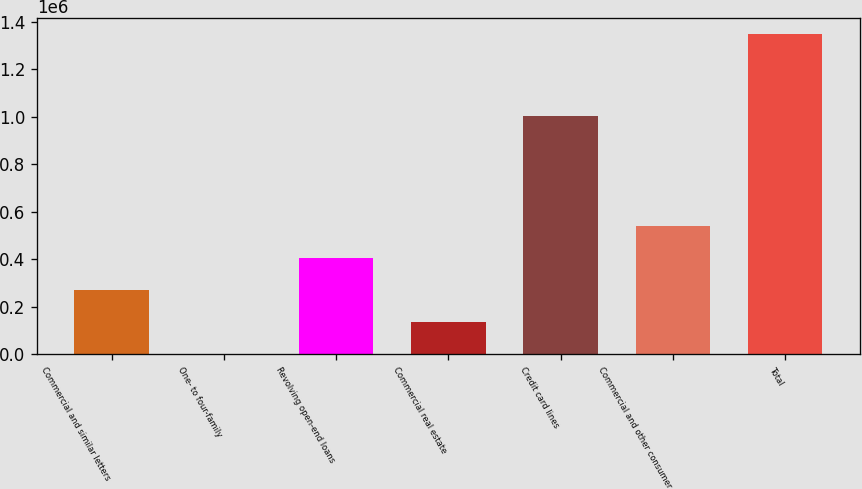Convert chart to OTSL. <chart><loc_0><loc_0><loc_500><loc_500><bar_chart><fcel>Commercial and similar letters<fcel>One- to four-family<fcel>Revolving open-end loans<fcel>Commercial real estate<fcel>Credit card lines<fcel>Commercial and other consumer<fcel>Total<nl><fcel>270650<fcel>937<fcel>405506<fcel>135793<fcel>1.00244e+06<fcel>540362<fcel>1.3495e+06<nl></chart> 